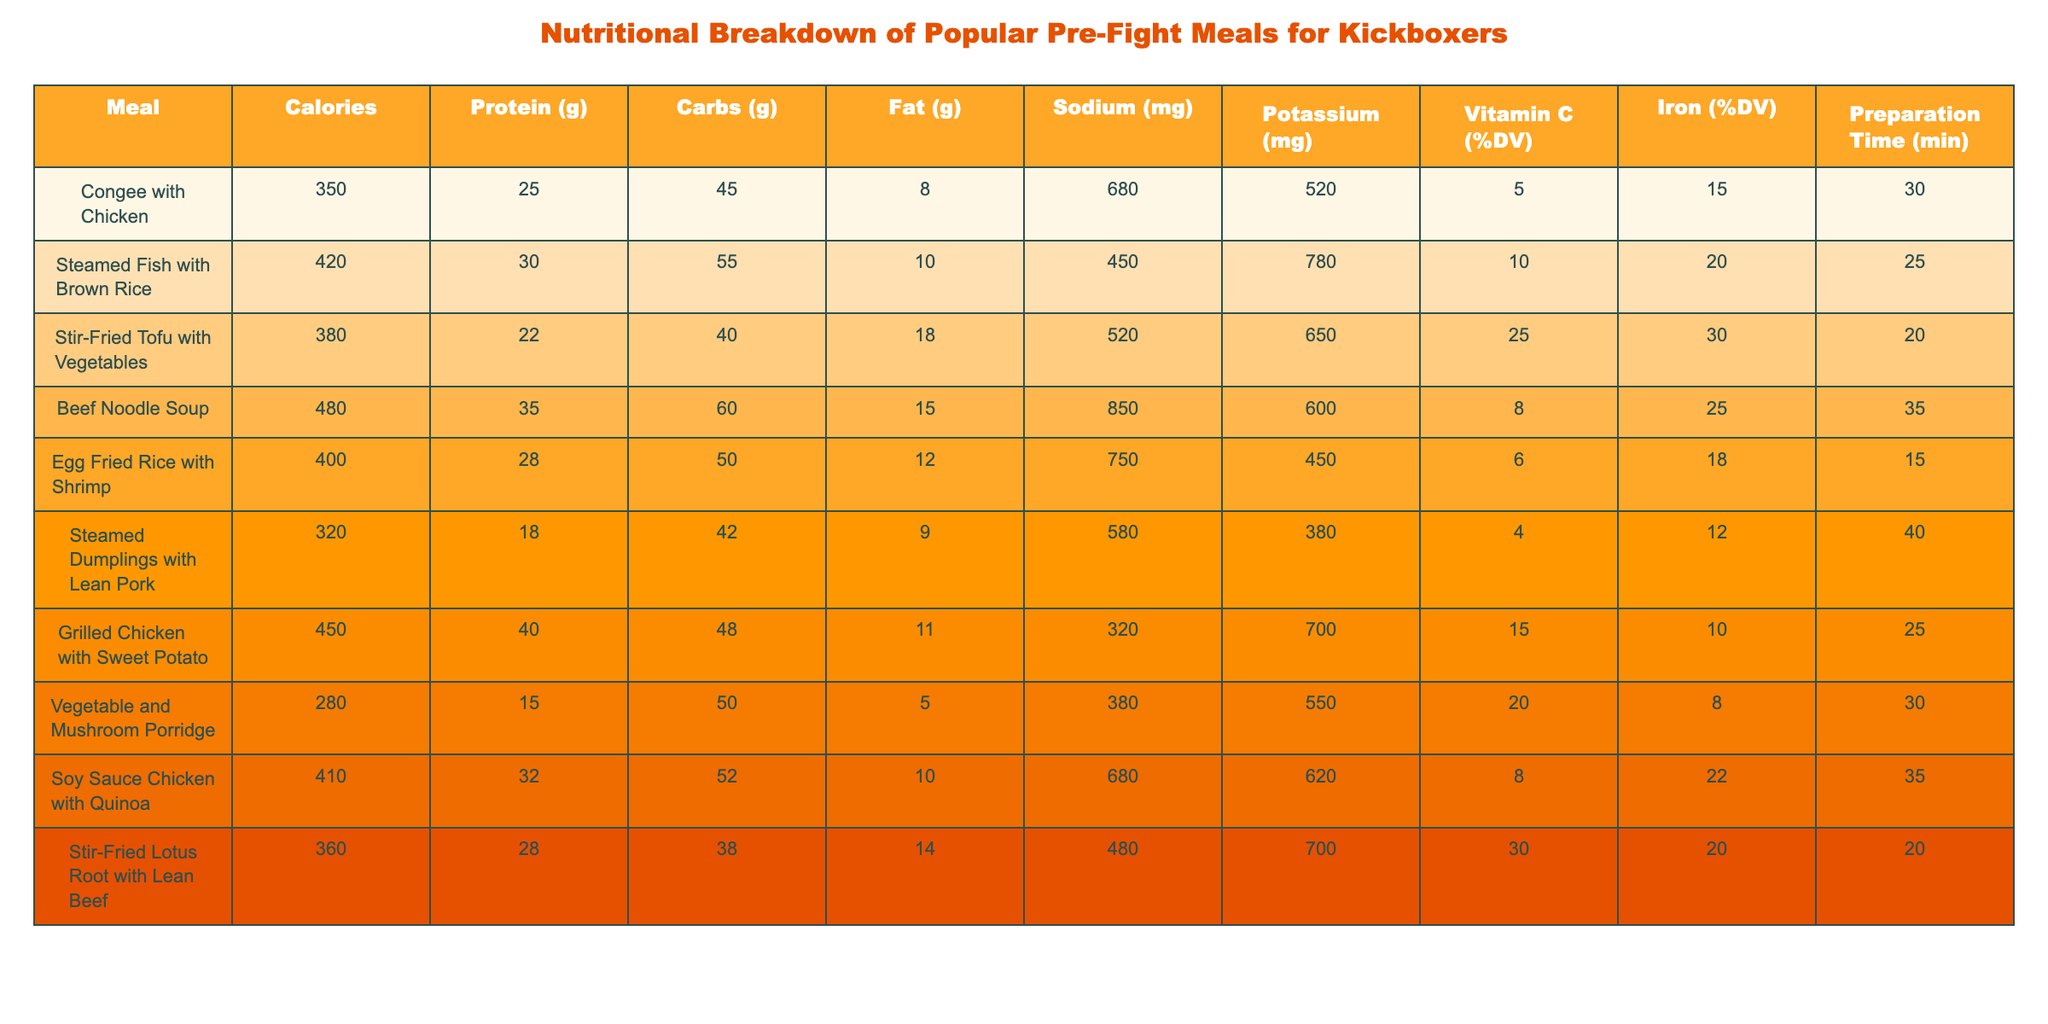What is the highest protein meal listed? By examining the protein column, the meal with the highest protein value is Beef Noodle Soup at 35 grams.
Answer: Beef Noodle Soup Which meal has the lowest sodium content? Looking at the sodium values, Vegetable and Mushroom Porridge has the lowest sodium content at 380 mg.
Answer: Vegetable and Mushroom Porridge What is the total calorie count of Grilled Chicken with Sweet Potato and Egg Fried Rice with Shrimp? Grilled Chicken with Sweet Potato has 450 calories and Egg Fried Rice with Shrimp has 400 calories. Adding them together: 450 + 400 = 850 calories.
Answer: 850 Is the Stir-Fried Tofu with Vegetables higher in fat than the Soy Sauce Chicken with Quinoa? Stir-Fried Tofu has 18 grams of fat, while Soy Sauce Chicken has 10 grams. Therefore, Stir-Fried Tofu has more fat than Soy Sauce Chicken.
Answer: Yes What is the average preparation time of all meals listed? Adding the preparation times together gives a total of 245 minutes for all meals (30 + 25 + 20 + 35 + 15 + 40 + 25 + 30 + 35 + 20), and dividing by the number of meals (10) yields an average of 24.5 minutes.
Answer: 24.5 Which meal provides the highest percentage of Vitamin C based on its daily value? Reviewing the Vitamin C (%DV) column, Stir-Fried Lotus Root with Lean Beef has the highest percentage at 30% of daily value.
Answer: Stir-Fried Lotus Root with Lean Beef How many grams of carbohydrates are in Congee with Chicken compared to Stir-Fried Tofu with Vegetables? Congee with Chicken has 45 grams of carbohydrates, while Stir-Fried Tofu has 40 grams. Thus, Congee has 5 grams more carbohydrates than Stir-Fried Tofu.
Answer: 5 grams more What percentage of daily value of iron is provided by the Beef Noodle Soup? The table indicates that Beef Noodle Soup provides 25% of the daily value for iron.
Answer: 25% Compare the potassium content between Steamed Fish with Brown Rice and Grilled Chicken with Sweet Potato. Which one has higher potassium? Steamed Fish has 780 mg of potassium, while Grilled Chicken has 700 mg. Therefore, Steamed Fish with Brown Rice has a higher potassium content.
Answer: Steamed Fish with Brown Rice What meal offers the least amount of fat and how much is it? Examining the fat column reveals that Vegetable and Mushroom Porridge has the least amount of fat at 5 grams.
Answer: Vegetable and Mushroom Porridge, 5 grams 